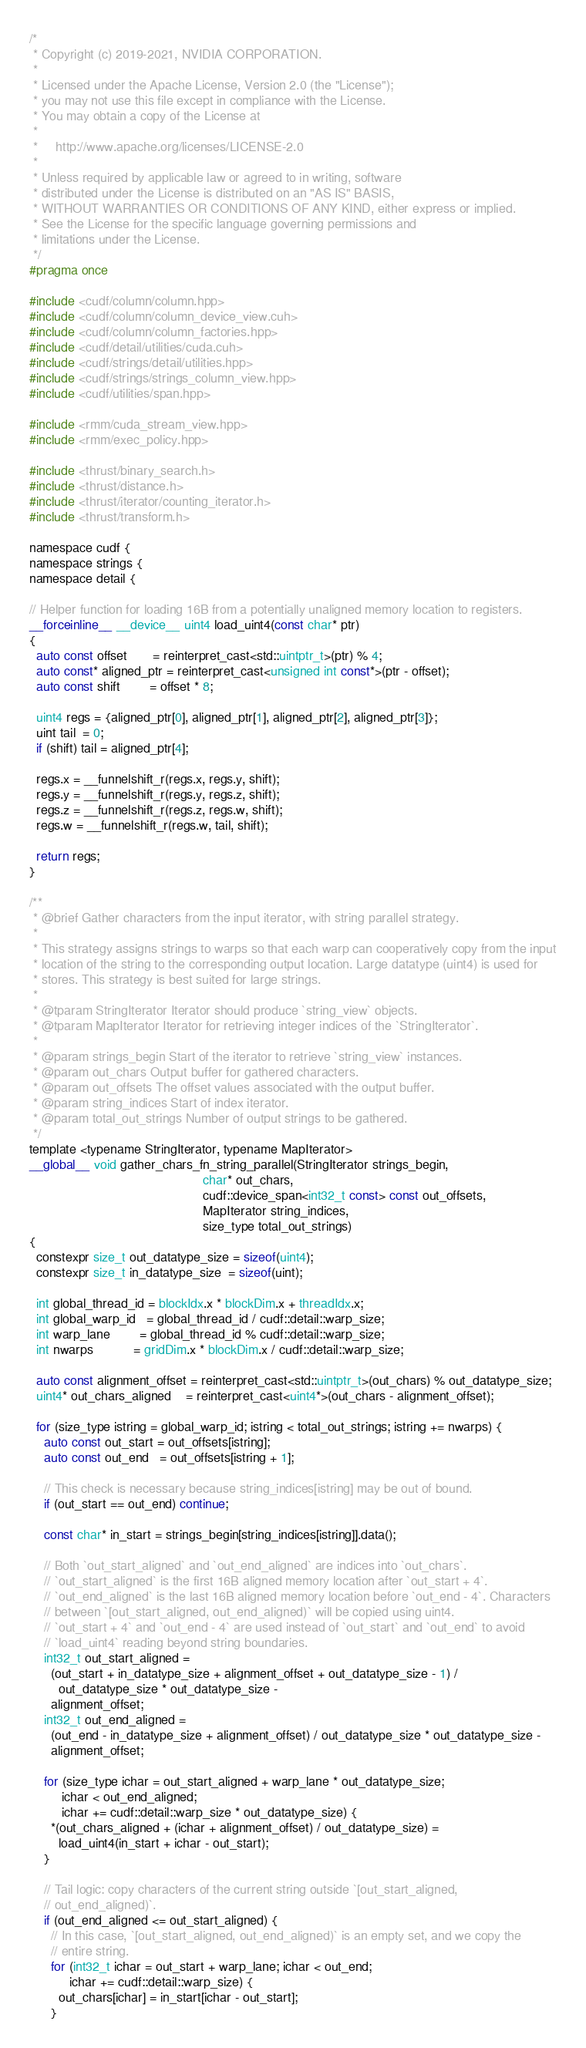Convert code to text. <code><loc_0><loc_0><loc_500><loc_500><_Cuda_>/*
 * Copyright (c) 2019-2021, NVIDIA CORPORATION.
 *
 * Licensed under the Apache License, Version 2.0 (the "License");
 * you may not use this file except in compliance with the License.
 * You may obtain a copy of the License at
 *
 *     http://www.apache.org/licenses/LICENSE-2.0
 *
 * Unless required by applicable law or agreed to in writing, software
 * distributed under the License is distributed on an "AS IS" BASIS,
 * WITHOUT WARRANTIES OR CONDITIONS OF ANY KIND, either express or implied.
 * See the License for the specific language governing permissions and
 * limitations under the License.
 */
#pragma once

#include <cudf/column/column.hpp>
#include <cudf/column/column_device_view.cuh>
#include <cudf/column/column_factories.hpp>
#include <cudf/detail/utilities/cuda.cuh>
#include <cudf/strings/detail/utilities.hpp>
#include <cudf/strings/strings_column_view.hpp>
#include <cudf/utilities/span.hpp>

#include <rmm/cuda_stream_view.hpp>
#include <rmm/exec_policy.hpp>

#include <thrust/binary_search.h>
#include <thrust/distance.h>
#include <thrust/iterator/counting_iterator.h>
#include <thrust/transform.h>

namespace cudf {
namespace strings {
namespace detail {

// Helper function for loading 16B from a potentially unaligned memory location to registers.
__forceinline__ __device__ uint4 load_uint4(const char* ptr)
{
  auto const offset       = reinterpret_cast<std::uintptr_t>(ptr) % 4;
  auto const* aligned_ptr = reinterpret_cast<unsigned int const*>(ptr - offset);
  auto const shift        = offset * 8;

  uint4 regs = {aligned_ptr[0], aligned_ptr[1], aligned_ptr[2], aligned_ptr[3]};
  uint tail  = 0;
  if (shift) tail = aligned_ptr[4];

  regs.x = __funnelshift_r(regs.x, regs.y, shift);
  regs.y = __funnelshift_r(regs.y, regs.z, shift);
  regs.z = __funnelshift_r(regs.z, regs.w, shift);
  regs.w = __funnelshift_r(regs.w, tail, shift);

  return regs;
}

/**
 * @brief Gather characters from the input iterator, with string parallel strategy.
 *
 * This strategy assigns strings to warps so that each warp can cooperatively copy from the input
 * location of the string to the corresponding output location. Large datatype (uint4) is used for
 * stores. This strategy is best suited for large strings.
 *
 * @tparam StringIterator Iterator should produce `string_view` objects.
 * @tparam MapIterator Iterator for retrieving integer indices of the `StringIterator`.
 *
 * @param strings_begin Start of the iterator to retrieve `string_view` instances.
 * @param out_chars Output buffer for gathered characters.
 * @param out_offsets The offset values associated with the output buffer.
 * @param string_indices Start of index iterator.
 * @param total_out_strings Number of output strings to be gathered.
 */
template <typename StringIterator, typename MapIterator>
__global__ void gather_chars_fn_string_parallel(StringIterator strings_begin,
                                                char* out_chars,
                                                cudf::device_span<int32_t const> const out_offsets,
                                                MapIterator string_indices,
                                                size_type total_out_strings)
{
  constexpr size_t out_datatype_size = sizeof(uint4);
  constexpr size_t in_datatype_size  = sizeof(uint);

  int global_thread_id = blockIdx.x * blockDim.x + threadIdx.x;
  int global_warp_id   = global_thread_id / cudf::detail::warp_size;
  int warp_lane        = global_thread_id % cudf::detail::warp_size;
  int nwarps           = gridDim.x * blockDim.x / cudf::detail::warp_size;

  auto const alignment_offset = reinterpret_cast<std::uintptr_t>(out_chars) % out_datatype_size;
  uint4* out_chars_aligned    = reinterpret_cast<uint4*>(out_chars - alignment_offset);

  for (size_type istring = global_warp_id; istring < total_out_strings; istring += nwarps) {
    auto const out_start = out_offsets[istring];
    auto const out_end   = out_offsets[istring + 1];

    // This check is necessary because string_indices[istring] may be out of bound.
    if (out_start == out_end) continue;

    const char* in_start = strings_begin[string_indices[istring]].data();

    // Both `out_start_aligned` and `out_end_aligned` are indices into `out_chars`.
    // `out_start_aligned` is the first 16B aligned memory location after `out_start + 4`.
    // `out_end_aligned` is the last 16B aligned memory location before `out_end - 4`. Characters
    // between `[out_start_aligned, out_end_aligned)` will be copied using uint4.
    // `out_start + 4` and `out_end - 4` are used instead of `out_start` and `out_end` to avoid
    // `load_uint4` reading beyond string boundaries.
    int32_t out_start_aligned =
      (out_start + in_datatype_size + alignment_offset + out_datatype_size - 1) /
        out_datatype_size * out_datatype_size -
      alignment_offset;
    int32_t out_end_aligned =
      (out_end - in_datatype_size + alignment_offset) / out_datatype_size * out_datatype_size -
      alignment_offset;

    for (size_type ichar = out_start_aligned + warp_lane * out_datatype_size;
         ichar < out_end_aligned;
         ichar += cudf::detail::warp_size * out_datatype_size) {
      *(out_chars_aligned + (ichar + alignment_offset) / out_datatype_size) =
        load_uint4(in_start + ichar - out_start);
    }

    // Tail logic: copy characters of the current string outside `[out_start_aligned,
    // out_end_aligned)`.
    if (out_end_aligned <= out_start_aligned) {
      // In this case, `[out_start_aligned, out_end_aligned)` is an empty set, and we copy the
      // entire string.
      for (int32_t ichar = out_start + warp_lane; ichar < out_end;
           ichar += cudf::detail::warp_size) {
        out_chars[ichar] = in_start[ichar - out_start];
      }</code> 